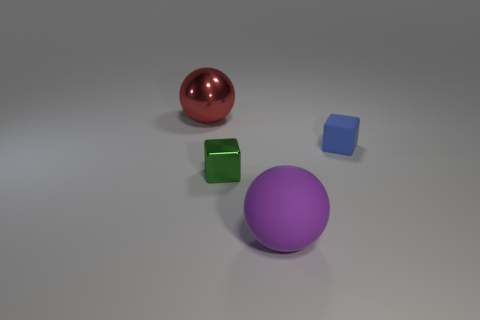Add 1 purple rubber spheres. How many objects exist? 5 Add 4 small green objects. How many small green objects are left? 5 Add 4 large brown cylinders. How many large brown cylinders exist? 4 Subtract 0 brown cylinders. How many objects are left? 4 Subtract all big shiny objects. Subtract all tiny blue matte things. How many objects are left? 2 